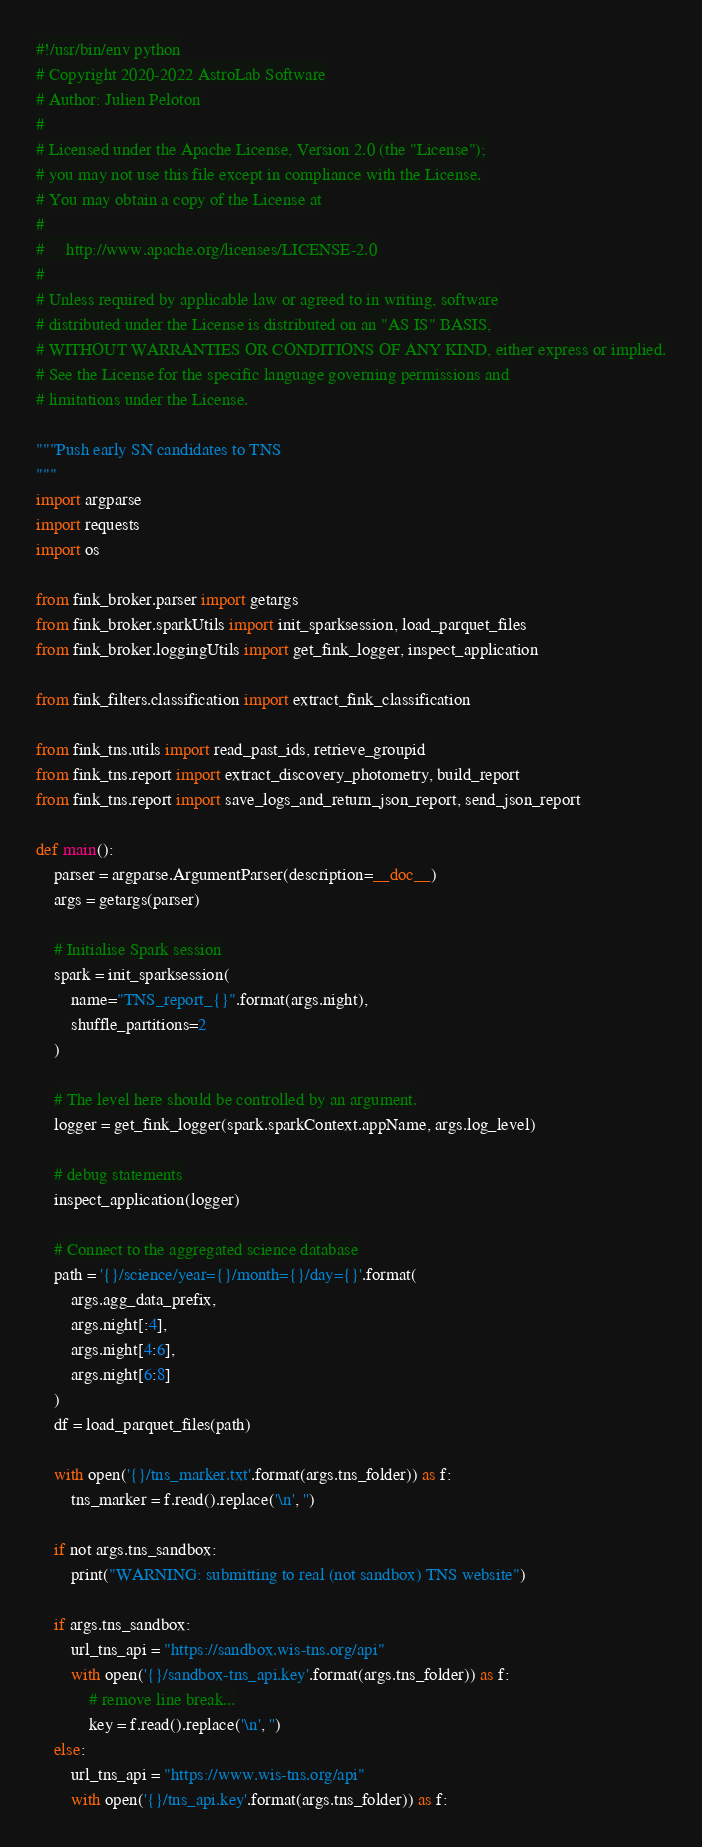Convert code to text. <code><loc_0><loc_0><loc_500><loc_500><_Python_>#!/usr/bin/env python
# Copyright 2020-2022 AstroLab Software
# Author: Julien Peloton
#
# Licensed under the Apache License, Version 2.0 (the "License");
# you may not use this file except in compliance with the License.
# You may obtain a copy of the License at
#
#     http://www.apache.org/licenses/LICENSE-2.0
#
# Unless required by applicable law or agreed to in writing, software
# distributed under the License is distributed on an "AS IS" BASIS,
# WITHOUT WARRANTIES OR CONDITIONS OF ANY KIND, either express or implied.
# See the License for the specific language governing permissions and
# limitations under the License.

"""Push early SN candidates to TNS
"""
import argparse
import requests
import os

from fink_broker.parser import getargs
from fink_broker.sparkUtils import init_sparksession, load_parquet_files
from fink_broker.loggingUtils import get_fink_logger, inspect_application

from fink_filters.classification import extract_fink_classification

from fink_tns.utils import read_past_ids, retrieve_groupid
from fink_tns.report import extract_discovery_photometry, build_report
from fink_tns.report import save_logs_and_return_json_report, send_json_report

def main():
    parser = argparse.ArgumentParser(description=__doc__)
    args = getargs(parser)

    # Initialise Spark session
    spark = init_sparksession(
        name="TNS_report_{}".format(args.night),
        shuffle_partitions=2
    )

    # The level here should be controlled by an argument.
    logger = get_fink_logger(spark.sparkContext.appName, args.log_level)

    # debug statements
    inspect_application(logger)

    # Connect to the aggregated science database
    path = '{}/science/year={}/month={}/day={}'.format(
        args.agg_data_prefix,
        args.night[:4],
        args.night[4:6],
        args.night[6:8]
    )
    df = load_parquet_files(path)

    with open('{}/tns_marker.txt'.format(args.tns_folder)) as f:
        tns_marker = f.read().replace('\n', '')

    if not args.tns_sandbox:
        print("WARNING: submitting to real (not sandbox) TNS website")

    if args.tns_sandbox:
        url_tns_api = "https://sandbox.wis-tns.org/api"
        with open('{}/sandbox-tns_api.key'.format(args.tns_folder)) as f:
            # remove line break...
            key = f.read().replace('\n', '')
    else:
        url_tns_api = "https://www.wis-tns.org/api"
        with open('{}/tns_api.key'.format(args.tns_folder)) as f:</code> 